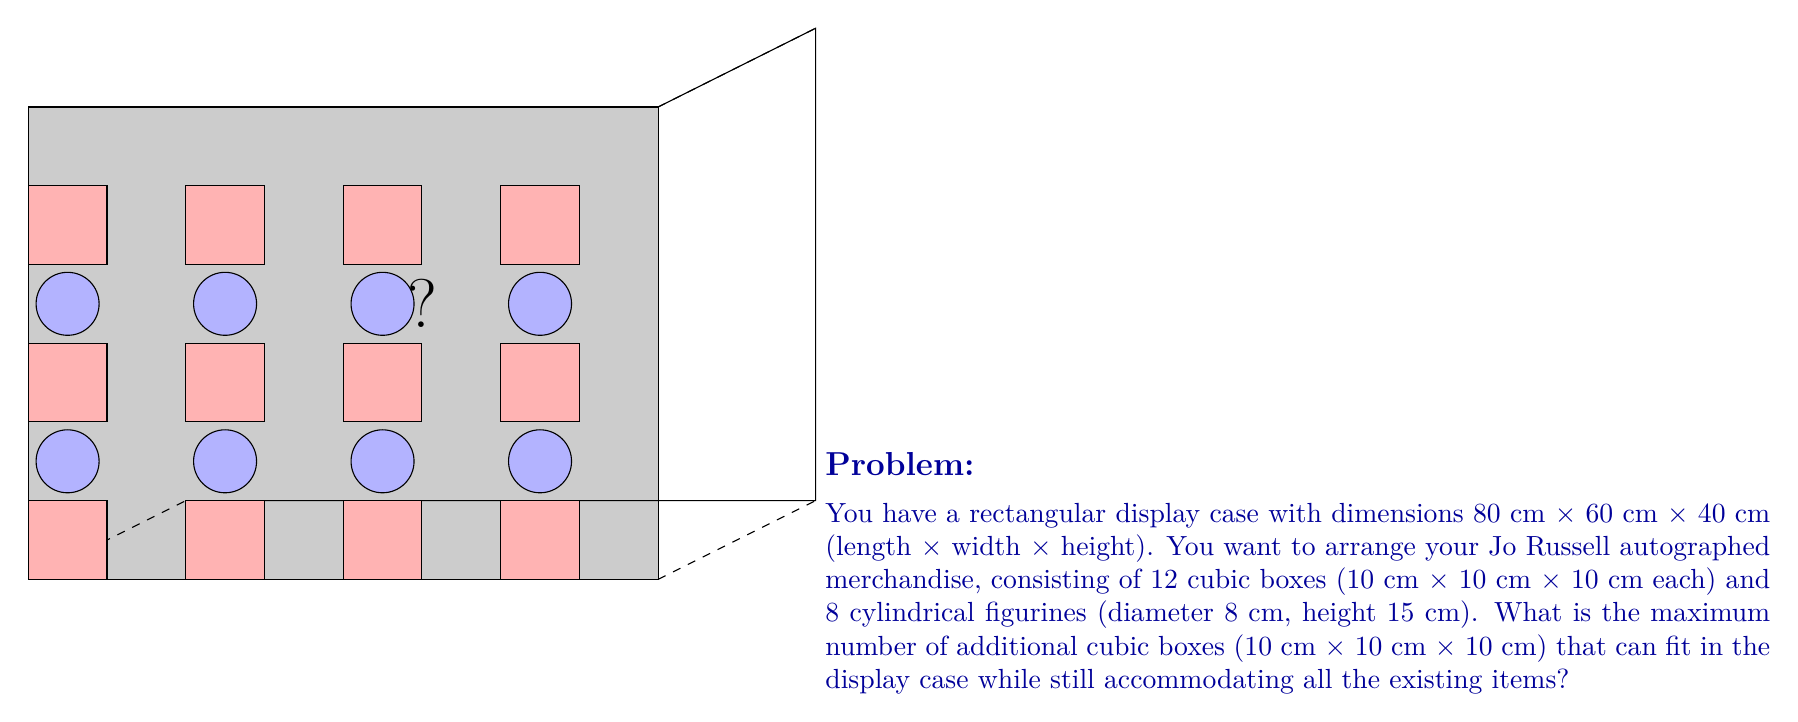Can you answer this question? Let's approach this step-by-step:

1) First, let's calculate the volume of the display case:
   $V_{case} = 80 \text{ cm} \times 60 \text{ cm} \times 40 \text{ cm} = 192,000 \text{ cm}^3$

2) Now, let's calculate the volume occupied by the existing items:
   - 12 cubic boxes: $12 \times (10 \text{ cm})^3 = 12,000 \text{ cm}^3$
   - 8 cylindrical figurines: $8 \times \pi \times (4 \text{ cm})^2 \times 15 \text{ cm} \approx 6,032 \text{ cm}^3$
   Total volume of existing items: $12,000 + 6,032 = 18,032 \text{ cm}^3$

3) Remaining volume: $192,000 \text{ cm}^3 - 18,032 \text{ cm}^3 = 173,968 \text{ cm}^3$

4) Volume of each additional cubic box: $(10 \text{ cm})^3 = 1,000 \text{ cm}^3$

5) Theoretically, the number of additional boxes that could fit:
   $173,968 \text{ cm}^3 \div 1,000 \text{ cm}^3 = 173.968$

6) However, we need to consider the spatial arrangement. The display case dimensions are multiples of 10 cm, which is convenient for the cubic boxes:
   - Length: 80 cm = 8 boxes
   - Width: 60 cm = 6 boxes
   - Height: 40 cm = 4 boxes

7) Total possible arrangement: $8 \times 6 \times 4 = 192$ boxes

8) We already have 12 cubic boxes and 8 cylindrical figurines. The figurines can be arranged in various ways, but they will occupy at least the space of 8 cubic boxes (since their height is greater than the cubic boxes).

9) Therefore, the maximum number of additional boxes:
   $192 - (12 + 8) = 172$
Answer: 172 